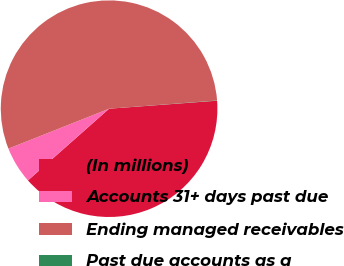Convert chart to OTSL. <chart><loc_0><loc_0><loc_500><loc_500><pie_chart><fcel>(In millions)<fcel>Accounts 31+ days past due<fcel>Ending managed receivables<fcel>Past due accounts as a<nl><fcel>39.66%<fcel>5.51%<fcel>54.81%<fcel>0.03%<nl></chart> 